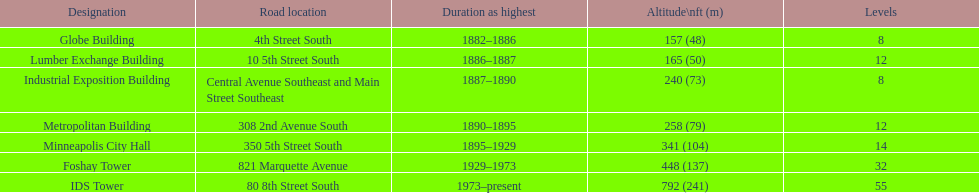How many floors does the foshay tower have? 32. 